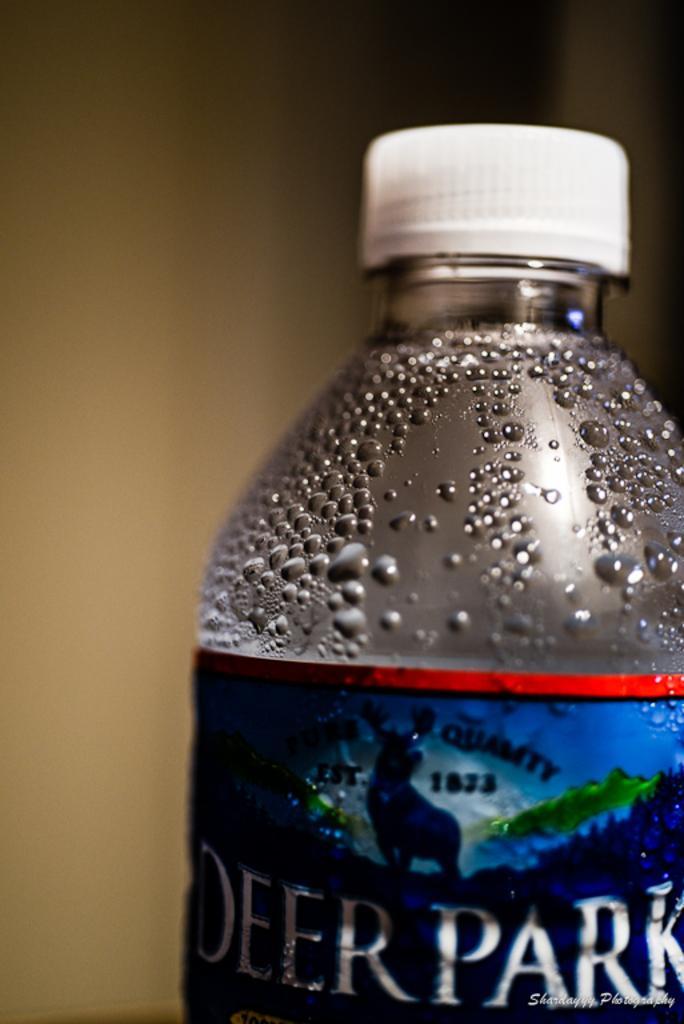In one or two sentences, can you explain what this image depicts? In this Image I see a bottle. 